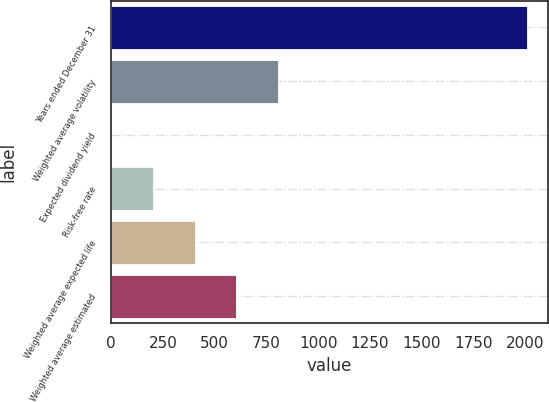Convert chart. <chart><loc_0><loc_0><loc_500><loc_500><bar_chart><fcel>Years ended December 31<fcel>Weighted average volatility<fcel>Expected dividend yield<fcel>Risk-free rate<fcel>Weighted average expected life<fcel>Weighted average estimated<nl><fcel>2008<fcel>804.04<fcel>1.4<fcel>202.06<fcel>402.72<fcel>603.38<nl></chart> 